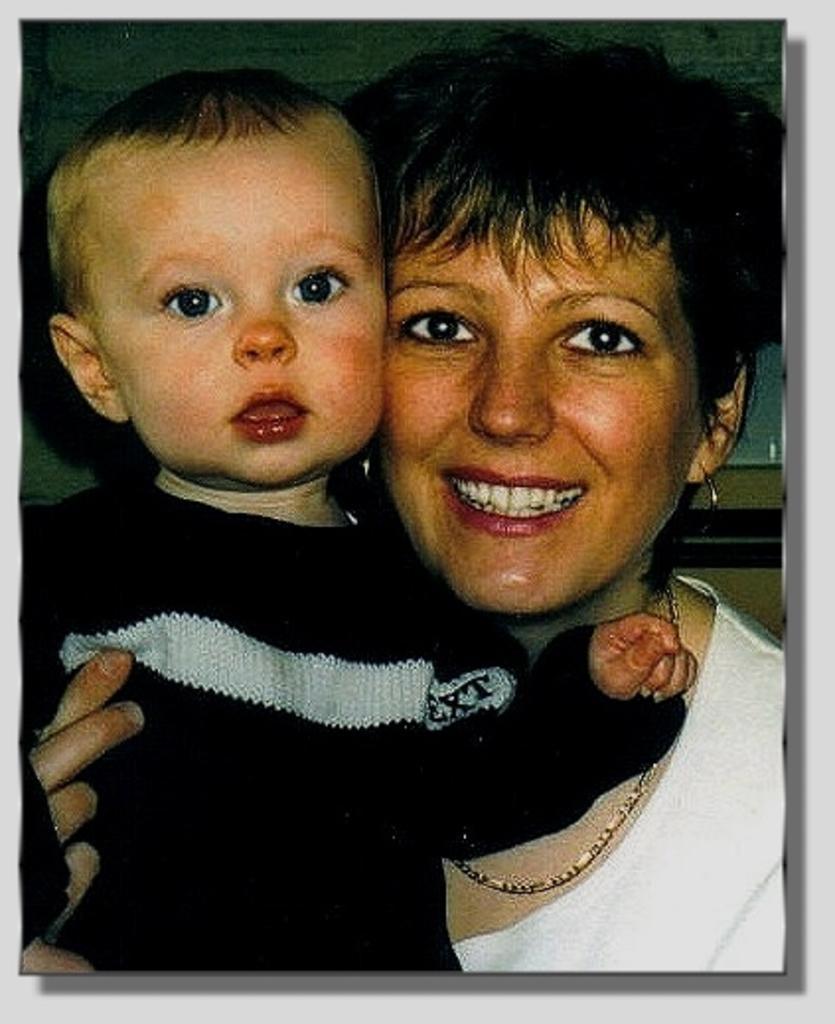Describe this image in one or two sentences. In this image we can see a smiling woman and also a boy and the image has borders. 